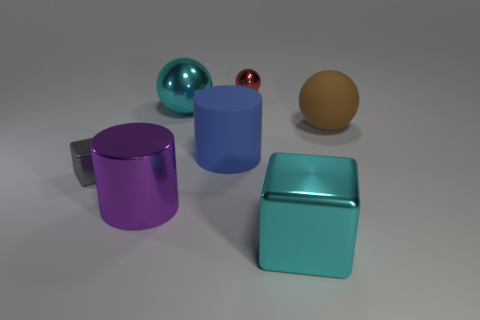What is the size of the sphere that is the same color as the large shiny cube?
Provide a short and direct response. Large. What is the color of the metallic sphere that is the same size as the rubber cylinder?
Keep it short and to the point. Cyan. What number of objects are shiny things behind the small cube or matte objects on the right side of the large cyan shiny block?
Make the answer very short. 3. Are there the same number of small metal cubes on the right side of the large matte ball and tiny red metallic cylinders?
Your answer should be very brief. Yes. Do the metallic cube that is on the left side of the large purple metallic cylinder and the cyan metallic object behind the gray metal block have the same size?
Your answer should be compact. No. How many other things are the same size as the cyan block?
Give a very brief answer. 4. Are there any things in front of the purple thing in front of the big cyan metallic object behind the gray shiny cube?
Make the answer very short. Yes. Are there any other things that have the same color as the big shiny block?
Keep it short and to the point. Yes. What is the size of the cylinder in front of the tiny block?
Make the answer very short. Large. There is a cylinder behind the large cylinder that is in front of the large cylinder to the right of the purple thing; what size is it?
Your answer should be compact. Large. 